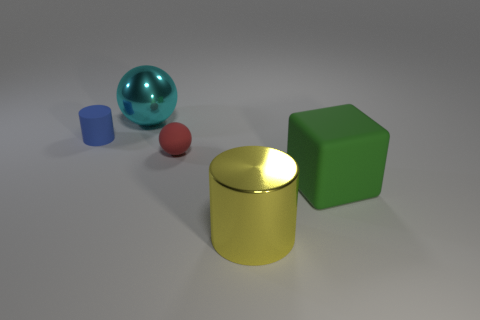Subtract all yellow cylinders. How many cylinders are left? 1 Add 2 large gray cubes. How many objects exist? 7 Subtract all cylinders. How many objects are left? 3 Subtract 1 cylinders. How many cylinders are left? 1 Subtract all gray balls. Subtract all blue cylinders. How many balls are left? 2 Subtract all yellow balls. How many yellow cylinders are left? 1 Subtract all big yellow metal things. Subtract all cyan shiny objects. How many objects are left? 3 Add 2 small red matte spheres. How many small red matte spheres are left? 3 Add 5 big green matte objects. How many big green matte objects exist? 6 Subtract 1 green cubes. How many objects are left? 4 